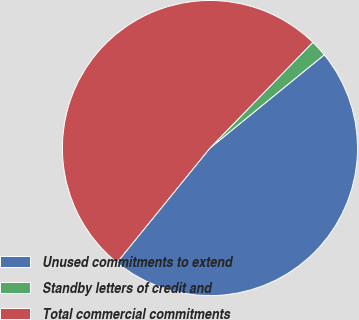Convert chart to OTSL. <chart><loc_0><loc_0><loc_500><loc_500><pie_chart><fcel>Unused commitments to extend<fcel>Standby letters of credit and<fcel>Total commercial commitments<nl><fcel>46.75%<fcel>1.83%<fcel>51.42%<nl></chart> 